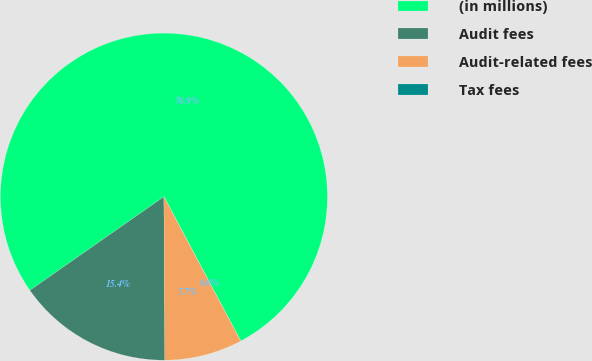Convert chart. <chart><loc_0><loc_0><loc_500><loc_500><pie_chart><fcel>(in millions)<fcel>Audit fees<fcel>Audit-related fees<fcel>Tax fees<nl><fcel>76.92%<fcel>15.39%<fcel>7.69%<fcel>0.0%<nl></chart> 